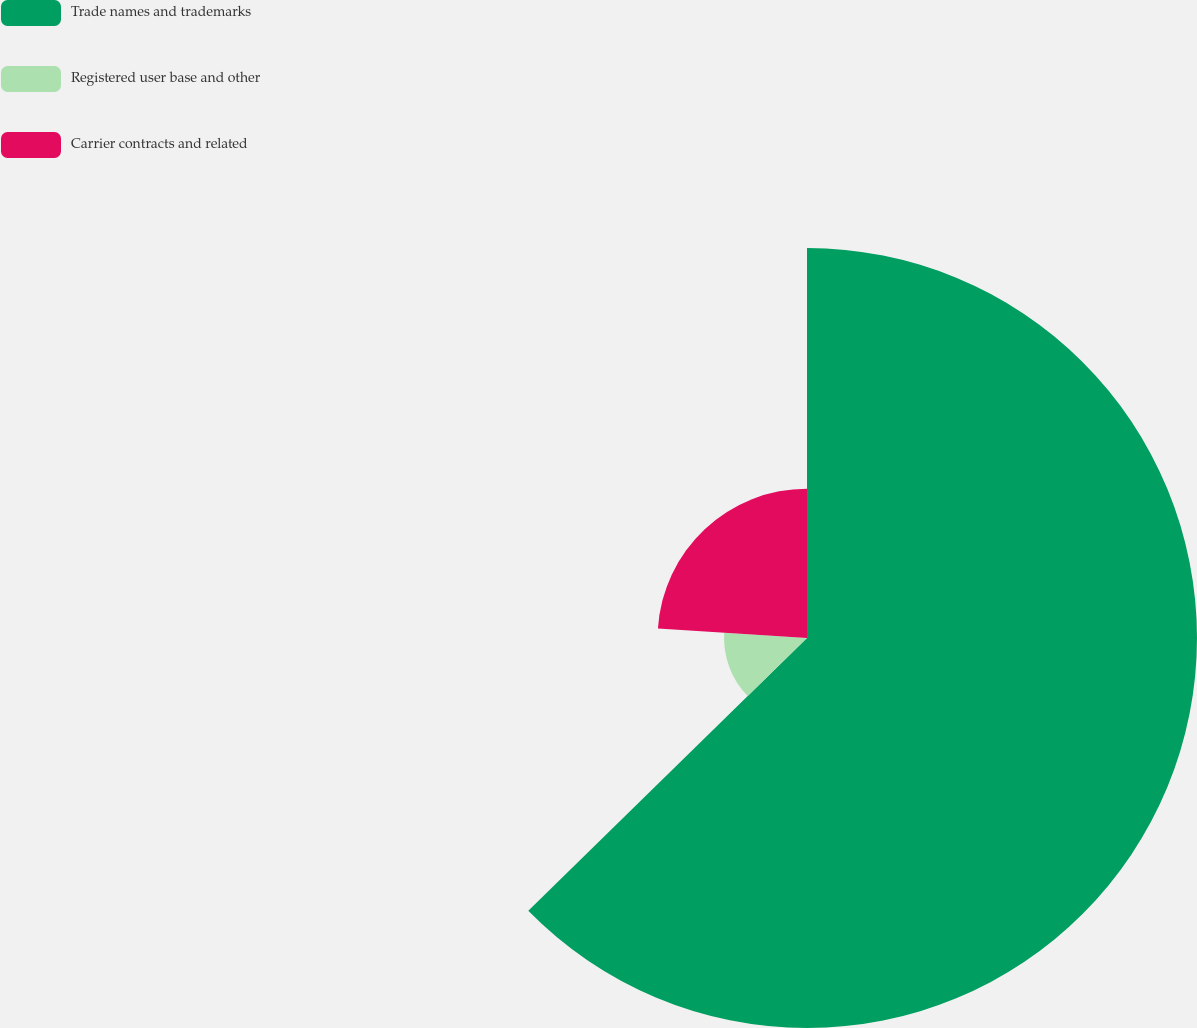Convert chart. <chart><loc_0><loc_0><loc_500><loc_500><pie_chart><fcel>Trade names and trademarks<fcel>Registered user base and other<fcel>Carrier contracts and related<nl><fcel>62.67%<fcel>13.33%<fcel>24.0%<nl></chart> 